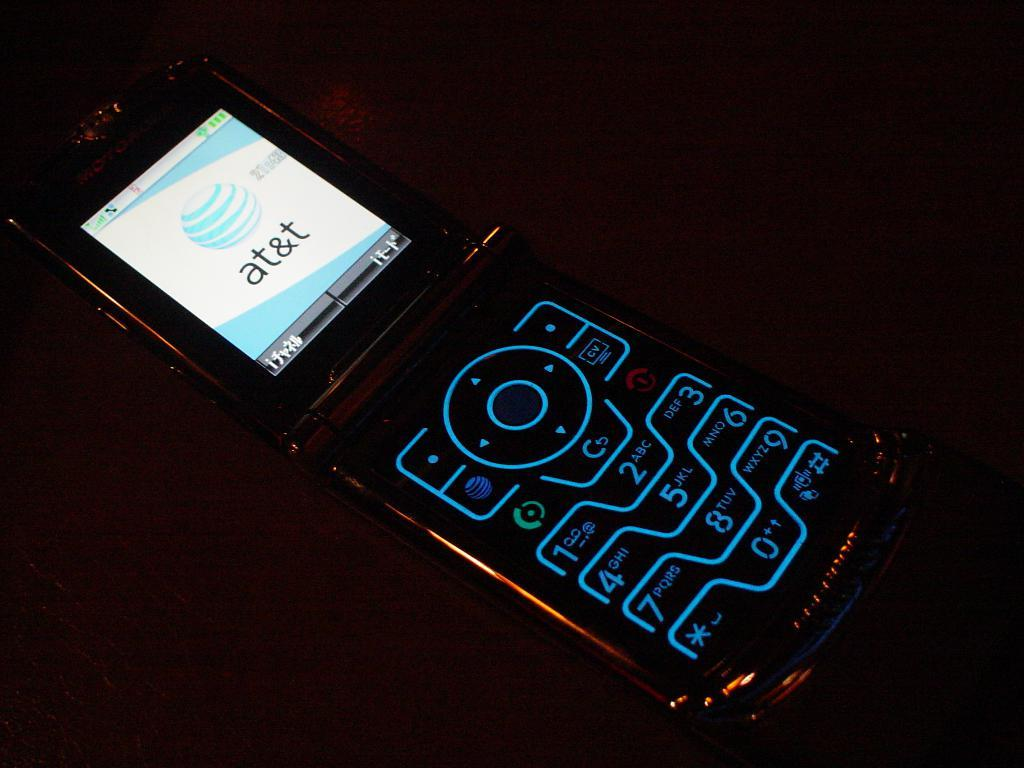<image>
Create a compact narrative representing the image presented. an old flip phone on the AT&T network 